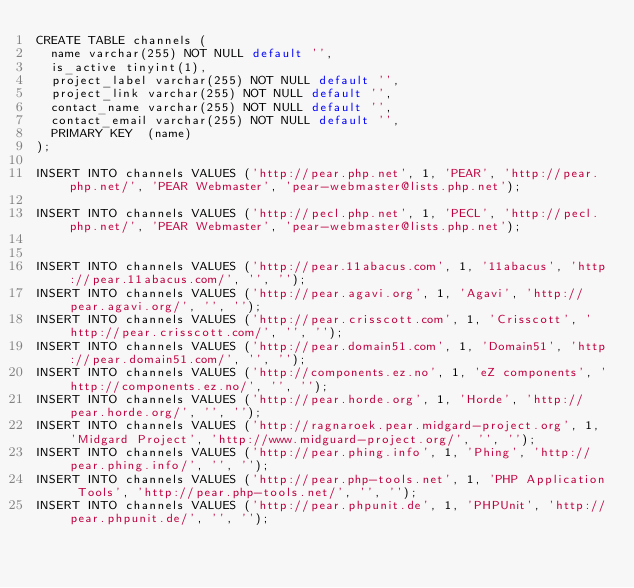<code> <loc_0><loc_0><loc_500><loc_500><_SQL_>CREATE TABLE channels (
  name varchar(255) NOT NULL default '', 
  is_active tinyint(1),
  project_label varchar(255) NOT NULL default '',
  project_link varchar(255) NOT NULL default '',
  contact_name varchar(255) NOT NULL default '',
  contact_email varchar(255) NOT NULL default '',
  PRIMARY KEY  (name)
);

INSERT INTO channels VALUES ('http://pear.php.net', 1, 'PEAR', 'http://pear.php.net/', 'PEAR Webmaster', 'pear-webmaster@lists.php.net');

INSERT INTO channels VALUES ('http://pecl.php.net', 1, 'PECL', 'http://pecl.php.net/', 'PEAR Webmaster', 'pear-webmaster@lists.php.net');


INSERT INTO channels VALUES ('http://pear.11abacus.com', 1, '11abacus', 'http://pear.11abacus.com/', '', '');
INSERT INTO channels VALUES ('http://pear.agavi.org', 1, 'Agavi', 'http://pear.agavi.org/', '', '');
INSERT INTO channels VALUES ('http://pear.crisscott.com', 1, 'Crisscott', 'http://pear.crisscott.com/', '', '');
INSERT INTO channels VALUES ('http://pear.domain51.com', 1, 'Domain51', 'http://pear.domain51.com/', '', '');
INSERT INTO channels VALUES ('http://components.ez.no', 1, 'eZ components', 'http://components.ez.no/', '', '');
INSERT INTO channels VALUES ('http://pear.horde.org', 1, 'Horde', 'http://pear.horde.org/', '', '');
INSERT INTO channels VALUES ('http://ragnaroek.pear.midgard-project.org', 1, 'Midgard Project', 'http://www.midguard-project.org/', '', '');
INSERT INTO channels VALUES ('http://pear.phing.info', 1, 'Phing', 'http://pear.phing.info/', '', '');
INSERT INTO channels VALUES ('http://pear.php-tools.net', 1, 'PHP Application Tools', 'http://pear.php-tools.net/', '', '');
INSERT INTO channels VALUES ('http://pear.phpunit.de', 1, 'PHPUnit', 'http://pear.phpunit.de/', '', '');</code> 